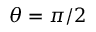<formula> <loc_0><loc_0><loc_500><loc_500>\theta = \pi / 2</formula> 